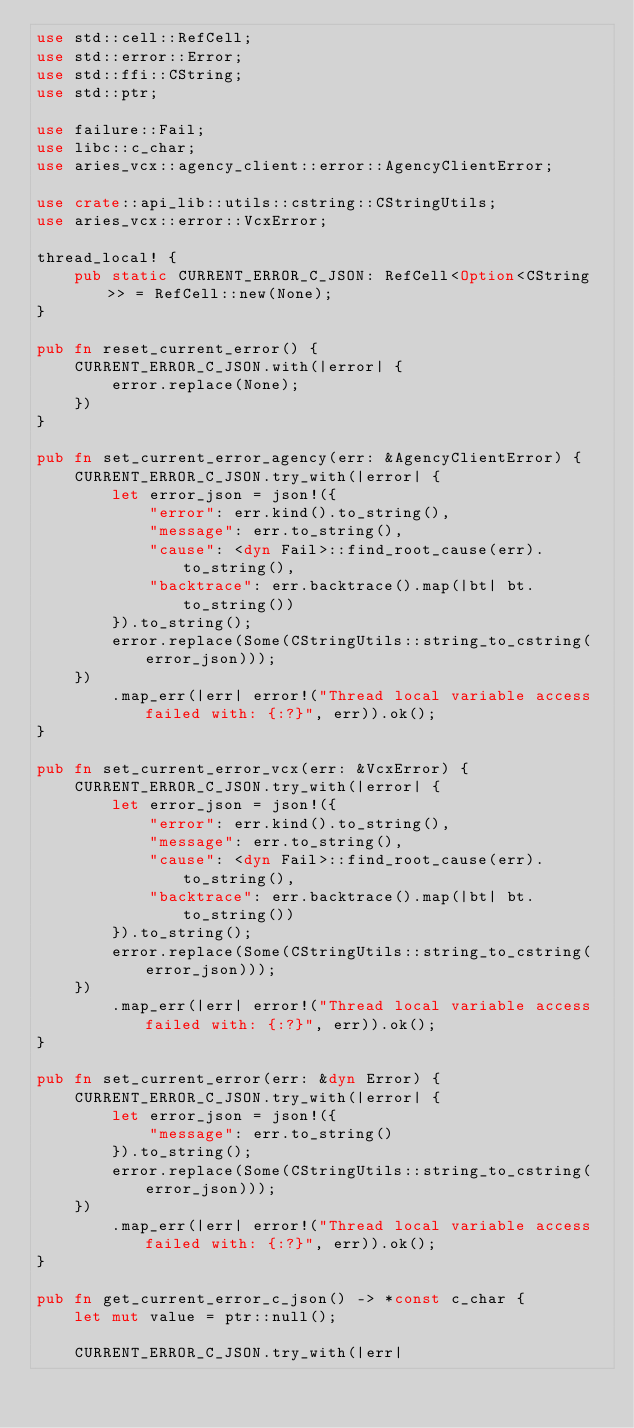Convert code to text. <code><loc_0><loc_0><loc_500><loc_500><_Rust_>use std::cell::RefCell;
use std::error::Error;
use std::ffi::CString;
use std::ptr;

use failure::Fail;
use libc::c_char;
use aries_vcx::agency_client::error::AgencyClientError;

use crate::api_lib::utils::cstring::CStringUtils;
use aries_vcx::error::VcxError;

thread_local! {
    pub static CURRENT_ERROR_C_JSON: RefCell<Option<CString>> = RefCell::new(None);
}

pub fn reset_current_error() {
    CURRENT_ERROR_C_JSON.with(|error| {
        error.replace(None);
    })
}

pub fn set_current_error_agency(err: &AgencyClientError) {
    CURRENT_ERROR_C_JSON.try_with(|error| {
        let error_json = json!({
            "error": err.kind().to_string(),
            "message": err.to_string(),
            "cause": <dyn Fail>::find_root_cause(err).to_string(),
            "backtrace": err.backtrace().map(|bt| bt.to_string())
        }).to_string();
        error.replace(Some(CStringUtils::string_to_cstring(error_json)));
    })
        .map_err(|err| error!("Thread local variable access failed with: {:?}", err)).ok();
}

pub fn set_current_error_vcx(err: &VcxError) {
    CURRENT_ERROR_C_JSON.try_with(|error| {
        let error_json = json!({
            "error": err.kind().to_string(),
            "message": err.to_string(),
            "cause": <dyn Fail>::find_root_cause(err).to_string(),
            "backtrace": err.backtrace().map(|bt| bt.to_string())
        }).to_string();
        error.replace(Some(CStringUtils::string_to_cstring(error_json)));
    })
        .map_err(|err| error!("Thread local variable access failed with: {:?}", err)).ok();
}

pub fn set_current_error(err: &dyn Error) {
    CURRENT_ERROR_C_JSON.try_with(|error| {
        let error_json = json!({
            "message": err.to_string()
        }).to_string();
        error.replace(Some(CStringUtils::string_to_cstring(error_json)));
    })
        .map_err(|err| error!("Thread local variable access failed with: {:?}", err)).ok();
}

pub fn get_current_error_c_json() -> *const c_char {
    let mut value = ptr::null();

    CURRENT_ERROR_C_JSON.try_with(|err|</code> 